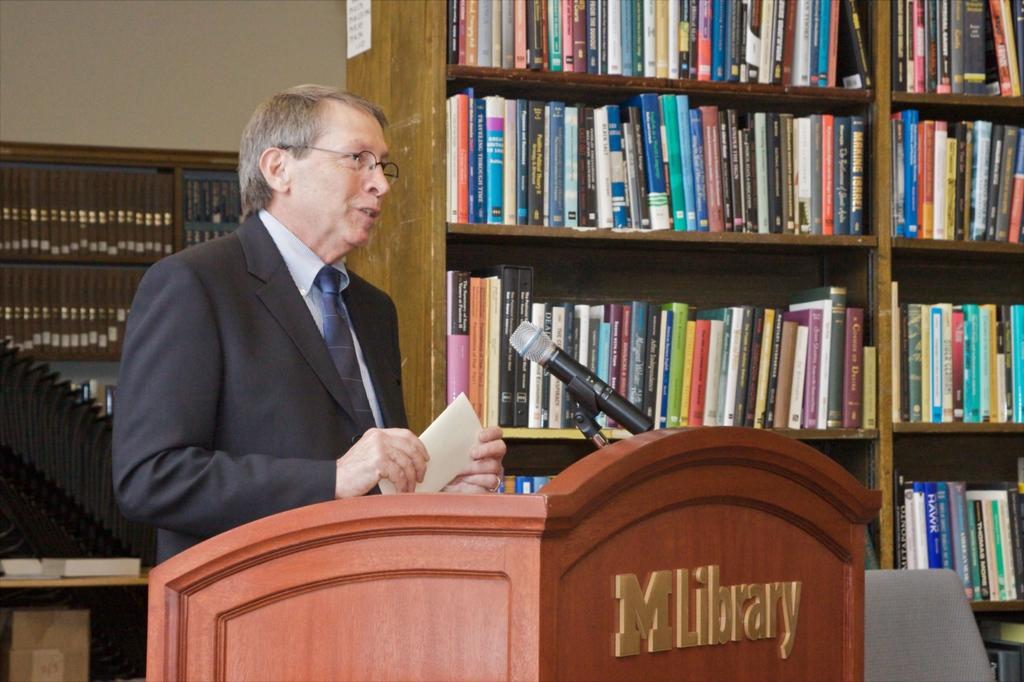What kind of library is this?
Provide a short and direct response. M library. 